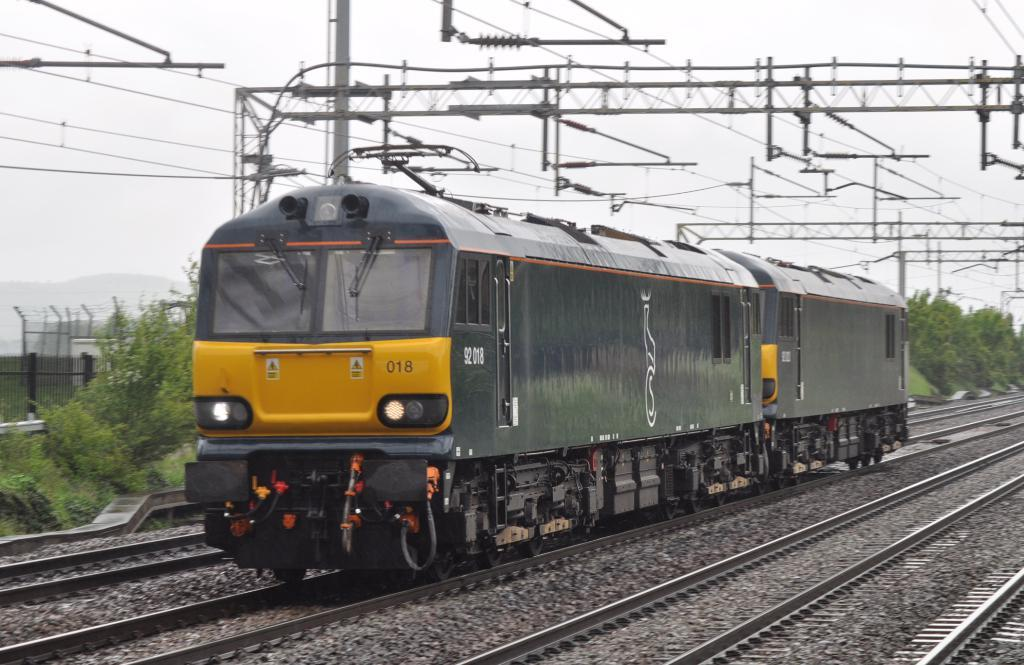<image>
Give a short and clear explanation of the subsequent image. Train number 018 only has two cars and is dark green in color with a stripe of yellow on the front. 